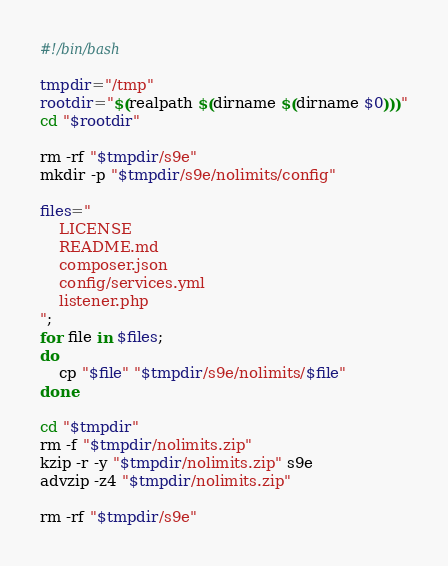Convert code to text. <code><loc_0><loc_0><loc_500><loc_500><_Bash_>#!/bin/bash

tmpdir="/tmp"
rootdir="$(realpath $(dirname $(dirname $0)))"
cd "$rootdir"

rm -rf "$tmpdir/s9e"
mkdir -p "$tmpdir/s9e/nolimits/config"

files="
	LICENSE
	README.md
	composer.json
	config/services.yml
	listener.php
";
for file in $files;
do
	cp "$file" "$tmpdir/s9e/nolimits/$file"
done

cd "$tmpdir"
rm -f "$tmpdir/nolimits.zip"
kzip -r -y "$tmpdir/nolimits.zip" s9e
advzip -z4 "$tmpdir/nolimits.zip"

rm -rf "$tmpdir/s9e"</code> 